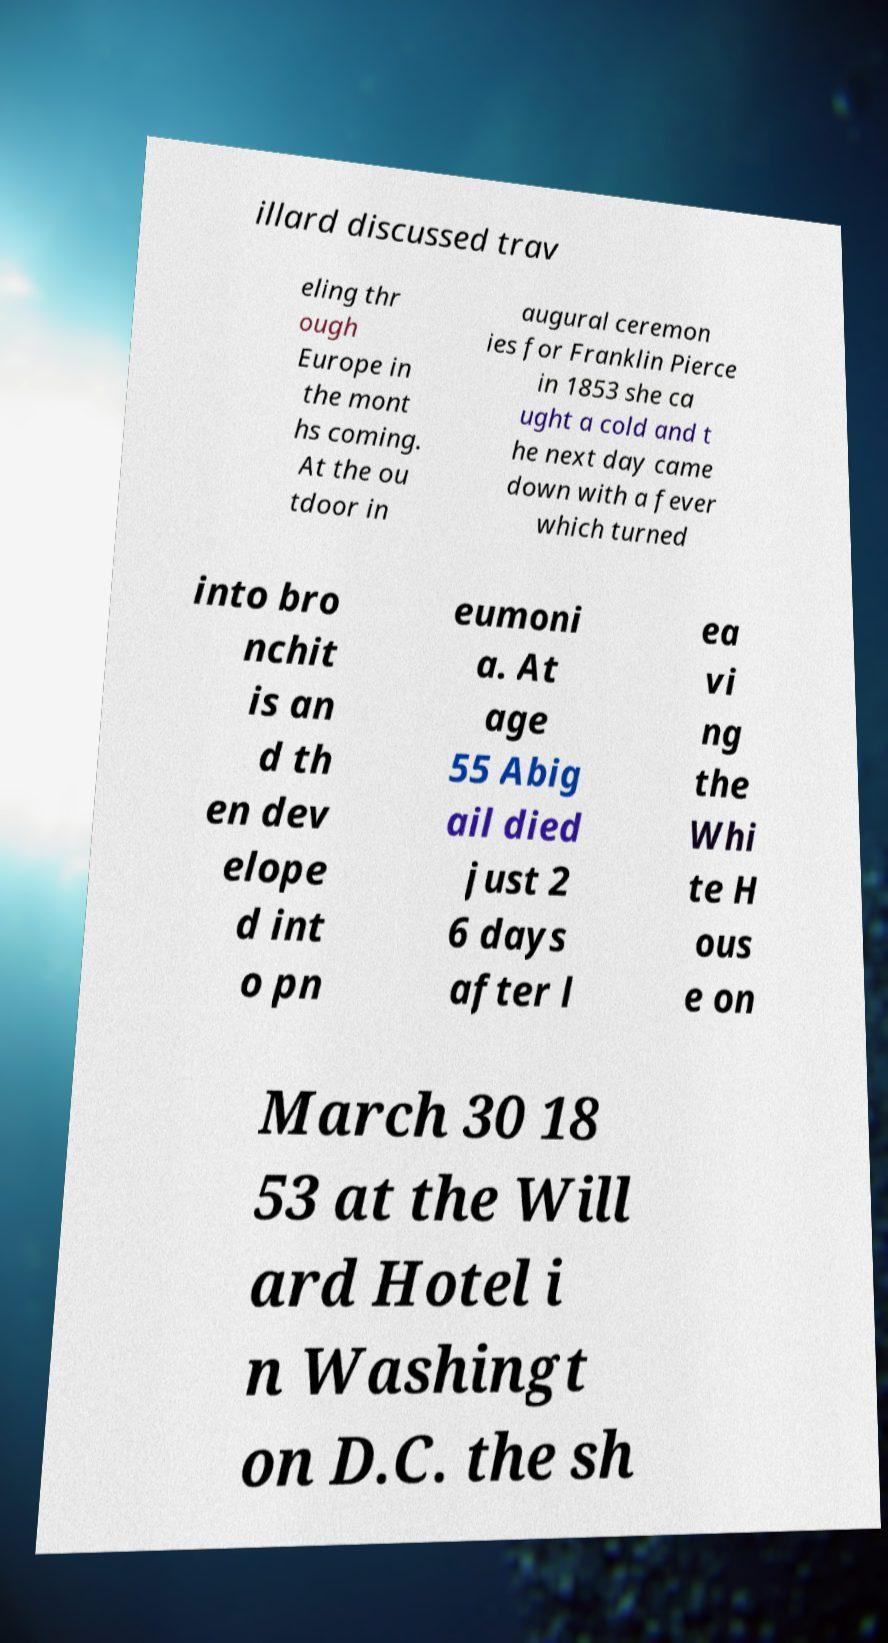I need the written content from this picture converted into text. Can you do that? illard discussed trav eling thr ough Europe in the mont hs coming. At the ou tdoor in augural ceremon ies for Franklin Pierce in 1853 she ca ught a cold and t he next day came down with a fever which turned into bro nchit is an d th en dev elope d int o pn eumoni a. At age 55 Abig ail died just 2 6 days after l ea vi ng the Whi te H ous e on March 30 18 53 at the Will ard Hotel i n Washingt on D.C. the sh 